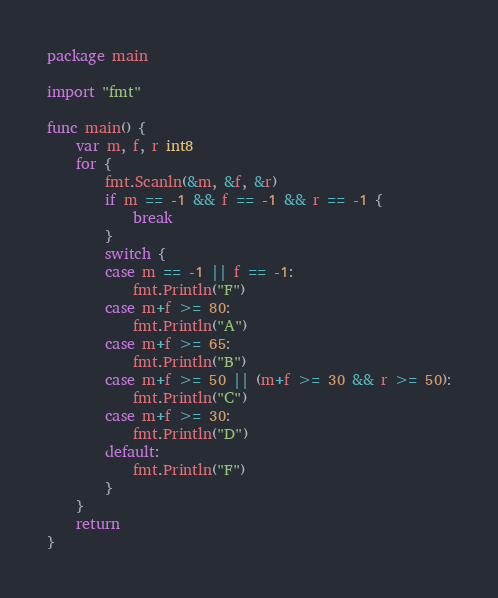<code> <loc_0><loc_0><loc_500><loc_500><_Go_>package main

import "fmt"

func main() {
	var m, f, r int8
	for {
		fmt.Scanln(&m, &f, &r)
		if m == -1 && f == -1 && r == -1 {
			break
		}
		switch {
		case m == -1 || f == -1:
			fmt.Println("F")
		case m+f >= 80:
			fmt.Println("A")
		case m+f >= 65:
			fmt.Println("B")
		case m+f >= 50 || (m+f >= 30 && r >= 50):
			fmt.Println("C")
		case m+f >= 30:
			fmt.Println("D")
		default:
			fmt.Println("F")
		}
	}
	return
}

</code> 